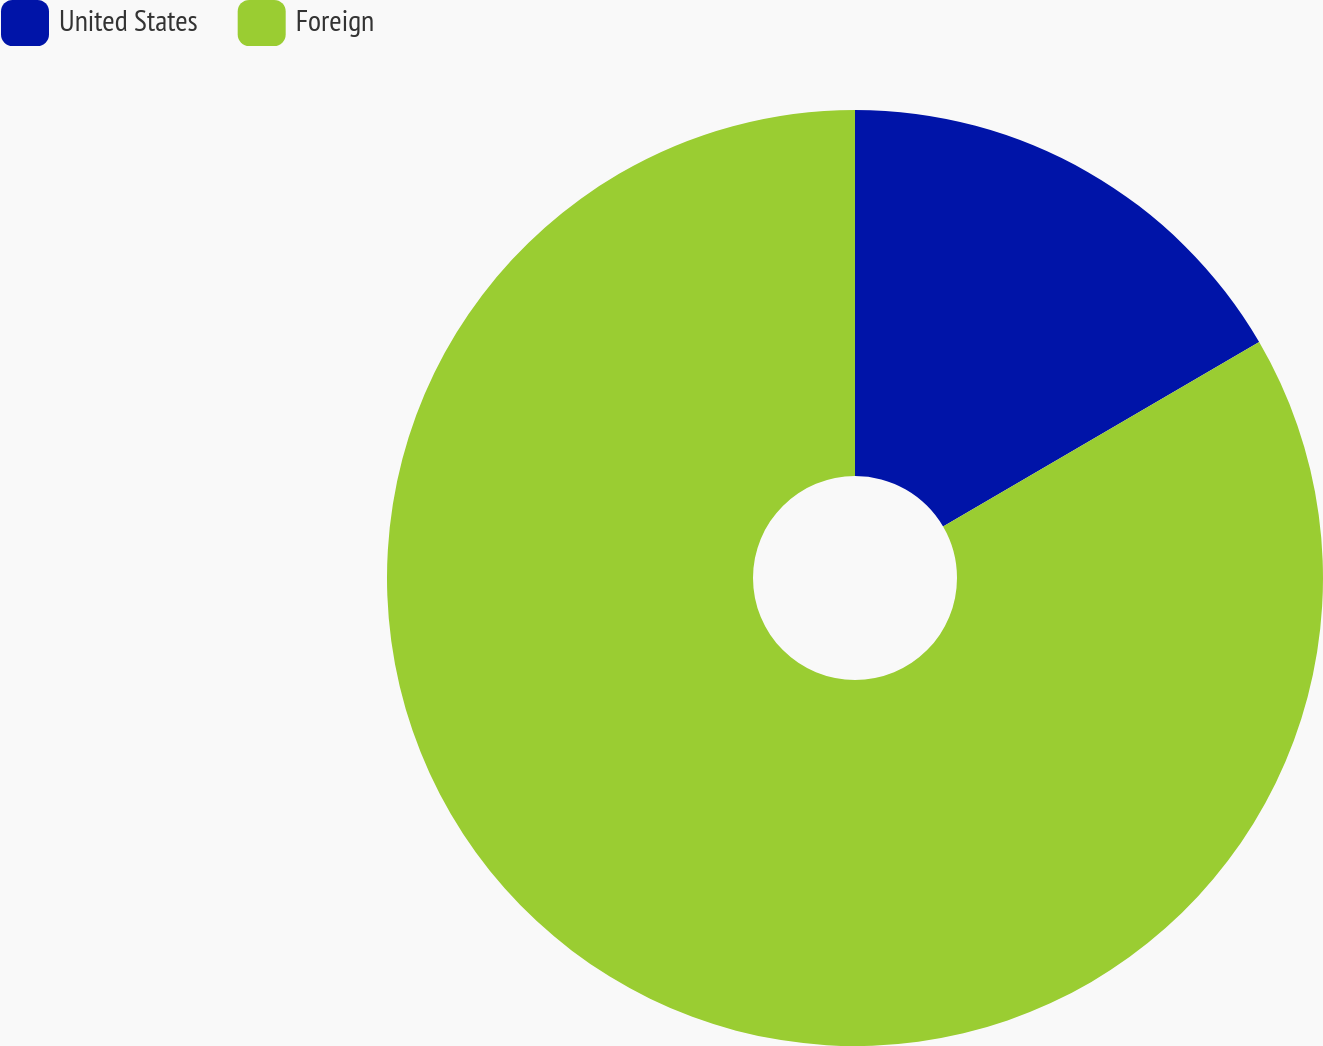Convert chart. <chart><loc_0><loc_0><loc_500><loc_500><pie_chart><fcel>United States<fcel>Foreign<nl><fcel>16.59%<fcel>83.41%<nl></chart> 